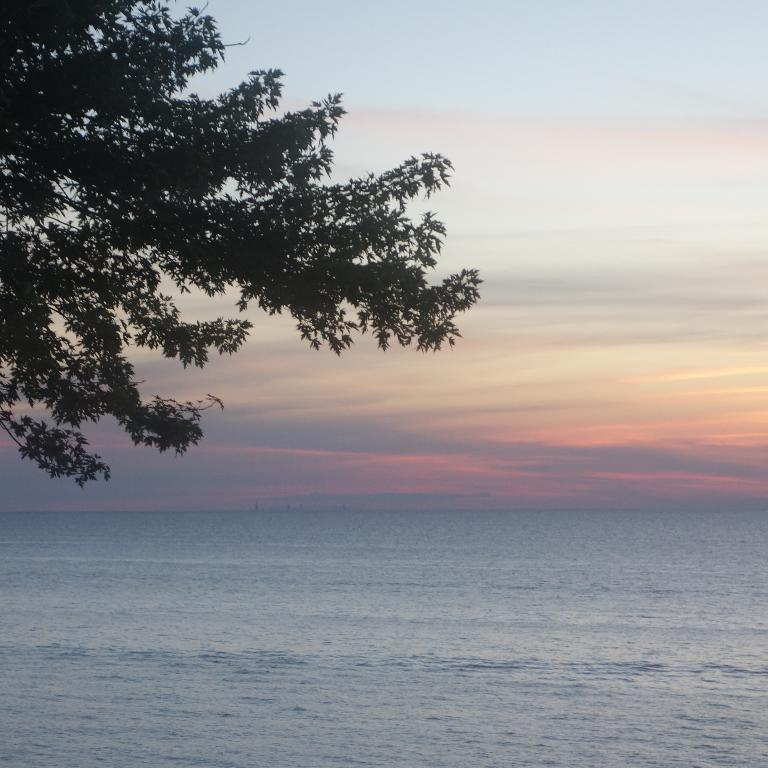What is the main feature in the foreground of the image? There is a water body in the foreground of the image. What can be seen in the middle of the image? There is a tree in the middle of the image. What is visible in the sky in the image? The sky is visible in the image, both in the middle and at the top. What type of experience can be gained from visiting the airport in the image? There is no airport present in the image, so it is not possible to gain any experience from visiting it. 